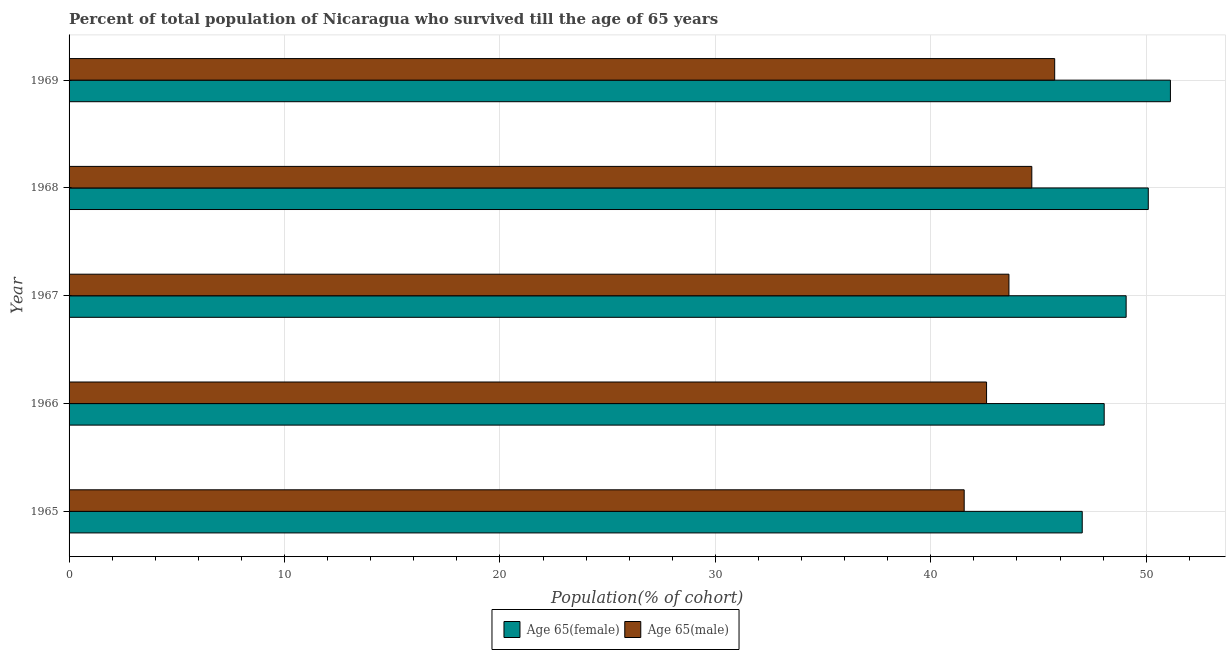How many groups of bars are there?
Give a very brief answer. 5. Are the number of bars per tick equal to the number of legend labels?
Keep it short and to the point. Yes. Are the number of bars on each tick of the Y-axis equal?
Your answer should be very brief. Yes. How many bars are there on the 1st tick from the bottom?
Your answer should be compact. 2. What is the label of the 4th group of bars from the top?
Give a very brief answer. 1966. What is the percentage of male population who survived till age of 65 in 1967?
Give a very brief answer. 43.63. Across all years, what is the maximum percentage of female population who survived till age of 65?
Your answer should be very brief. 51.12. Across all years, what is the minimum percentage of female population who survived till age of 65?
Offer a terse response. 47.03. In which year was the percentage of male population who survived till age of 65 maximum?
Keep it short and to the point. 1969. In which year was the percentage of female population who survived till age of 65 minimum?
Your response must be concise. 1965. What is the total percentage of female population who survived till age of 65 in the graph?
Give a very brief answer. 245.36. What is the difference between the percentage of female population who survived till age of 65 in 1965 and that in 1967?
Make the answer very short. -2.04. What is the difference between the percentage of male population who survived till age of 65 in 1968 and the percentage of female population who survived till age of 65 in 1969?
Keep it short and to the point. -6.43. What is the average percentage of female population who survived till age of 65 per year?
Keep it short and to the point. 49.07. In the year 1966, what is the difference between the percentage of male population who survived till age of 65 and percentage of female population who survived till age of 65?
Make the answer very short. -5.46. In how many years, is the percentage of female population who survived till age of 65 greater than 22 %?
Provide a succinct answer. 5. Is the percentage of female population who survived till age of 65 in 1966 less than that in 1969?
Offer a very short reply. Yes. What is the difference between the highest and the second highest percentage of male population who survived till age of 65?
Offer a terse response. 1.06. What is the difference between the highest and the lowest percentage of male population who survived till age of 65?
Offer a terse response. 4.2. In how many years, is the percentage of female population who survived till age of 65 greater than the average percentage of female population who survived till age of 65 taken over all years?
Provide a succinct answer. 2. What does the 1st bar from the top in 1965 represents?
Offer a very short reply. Age 65(male). What does the 2nd bar from the bottom in 1966 represents?
Make the answer very short. Age 65(male). How many bars are there?
Provide a short and direct response. 10. How many years are there in the graph?
Give a very brief answer. 5. What is the difference between two consecutive major ticks on the X-axis?
Offer a terse response. 10. Are the values on the major ticks of X-axis written in scientific E-notation?
Provide a succinct answer. No. Does the graph contain any zero values?
Give a very brief answer. No. Does the graph contain grids?
Ensure brevity in your answer.  Yes. Where does the legend appear in the graph?
Provide a short and direct response. Bottom center. How many legend labels are there?
Give a very brief answer. 2. How are the legend labels stacked?
Your answer should be very brief. Horizontal. What is the title of the graph?
Offer a terse response. Percent of total population of Nicaragua who survived till the age of 65 years. What is the label or title of the X-axis?
Offer a very short reply. Population(% of cohort). What is the label or title of the Y-axis?
Give a very brief answer. Year. What is the Population(% of cohort) of Age 65(female) in 1965?
Provide a short and direct response. 47.03. What is the Population(% of cohort) of Age 65(male) in 1965?
Make the answer very short. 41.55. What is the Population(% of cohort) in Age 65(female) in 1966?
Keep it short and to the point. 48.05. What is the Population(% of cohort) in Age 65(male) in 1966?
Your response must be concise. 42.59. What is the Population(% of cohort) in Age 65(female) in 1967?
Provide a short and direct response. 49.07. What is the Population(% of cohort) in Age 65(male) in 1967?
Make the answer very short. 43.63. What is the Population(% of cohort) in Age 65(female) in 1968?
Your answer should be compact. 50.09. What is the Population(% of cohort) in Age 65(male) in 1968?
Your response must be concise. 44.69. What is the Population(% of cohort) of Age 65(female) in 1969?
Your answer should be compact. 51.12. What is the Population(% of cohort) in Age 65(male) in 1969?
Offer a very short reply. 45.75. Across all years, what is the maximum Population(% of cohort) of Age 65(female)?
Your response must be concise. 51.12. Across all years, what is the maximum Population(% of cohort) in Age 65(male)?
Provide a short and direct response. 45.75. Across all years, what is the minimum Population(% of cohort) in Age 65(female)?
Ensure brevity in your answer.  47.03. Across all years, what is the minimum Population(% of cohort) in Age 65(male)?
Ensure brevity in your answer.  41.55. What is the total Population(% of cohort) of Age 65(female) in the graph?
Make the answer very short. 245.36. What is the total Population(% of cohort) in Age 65(male) in the graph?
Provide a short and direct response. 218.2. What is the difference between the Population(% of cohort) of Age 65(female) in 1965 and that in 1966?
Ensure brevity in your answer.  -1.02. What is the difference between the Population(% of cohort) in Age 65(male) in 1965 and that in 1966?
Offer a terse response. -1.04. What is the difference between the Population(% of cohort) in Age 65(female) in 1965 and that in 1967?
Give a very brief answer. -2.04. What is the difference between the Population(% of cohort) in Age 65(male) in 1965 and that in 1967?
Give a very brief answer. -2.08. What is the difference between the Population(% of cohort) in Age 65(female) in 1965 and that in 1968?
Make the answer very short. -3.07. What is the difference between the Population(% of cohort) in Age 65(male) in 1965 and that in 1968?
Your answer should be compact. -3.14. What is the difference between the Population(% of cohort) in Age 65(female) in 1965 and that in 1969?
Make the answer very short. -4.09. What is the difference between the Population(% of cohort) of Age 65(male) in 1965 and that in 1969?
Provide a short and direct response. -4.2. What is the difference between the Population(% of cohort) in Age 65(female) in 1966 and that in 1967?
Ensure brevity in your answer.  -1.02. What is the difference between the Population(% of cohort) of Age 65(male) in 1966 and that in 1967?
Offer a terse response. -1.04. What is the difference between the Population(% of cohort) of Age 65(female) in 1966 and that in 1968?
Your answer should be compact. -2.05. What is the difference between the Population(% of cohort) in Age 65(male) in 1966 and that in 1968?
Offer a terse response. -2.1. What is the difference between the Population(% of cohort) of Age 65(female) in 1966 and that in 1969?
Provide a short and direct response. -3.07. What is the difference between the Population(% of cohort) in Age 65(male) in 1966 and that in 1969?
Provide a short and direct response. -3.16. What is the difference between the Population(% of cohort) of Age 65(female) in 1967 and that in 1968?
Provide a short and direct response. -1.03. What is the difference between the Population(% of cohort) in Age 65(male) in 1967 and that in 1968?
Provide a succinct answer. -1.06. What is the difference between the Population(% of cohort) of Age 65(female) in 1967 and that in 1969?
Provide a succinct answer. -2.06. What is the difference between the Population(% of cohort) of Age 65(male) in 1967 and that in 1969?
Provide a short and direct response. -2.12. What is the difference between the Population(% of cohort) of Age 65(female) in 1968 and that in 1969?
Your answer should be very brief. -1.03. What is the difference between the Population(% of cohort) in Age 65(male) in 1968 and that in 1969?
Offer a terse response. -1.06. What is the difference between the Population(% of cohort) in Age 65(female) in 1965 and the Population(% of cohort) in Age 65(male) in 1966?
Provide a short and direct response. 4.44. What is the difference between the Population(% of cohort) in Age 65(female) in 1965 and the Population(% of cohort) in Age 65(male) in 1967?
Make the answer very short. 3.4. What is the difference between the Population(% of cohort) in Age 65(female) in 1965 and the Population(% of cohort) in Age 65(male) in 1968?
Ensure brevity in your answer.  2.34. What is the difference between the Population(% of cohort) in Age 65(female) in 1965 and the Population(% of cohort) in Age 65(male) in 1969?
Provide a short and direct response. 1.28. What is the difference between the Population(% of cohort) in Age 65(female) in 1966 and the Population(% of cohort) in Age 65(male) in 1967?
Your response must be concise. 4.42. What is the difference between the Population(% of cohort) of Age 65(female) in 1966 and the Population(% of cohort) of Age 65(male) in 1968?
Your answer should be very brief. 3.36. What is the difference between the Population(% of cohort) of Age 65(female) in 1966 and the Population(% of cohort) of Age 65(male) in 1969?
Make the answer very short. 2.3. What is the difference between the Population(% of cohort) of Age 65(female) in 1967 and the Population(% of cohort) of Age 65(male) in 1968?
Your response must be concise. 4.38. What is the difference between the Population(% of cohort) in Age 65(female) in 1967 and the Population(% of cohort) in Age 65(male) in 1969?
Make the answer very short. 3.32. What is the difference between the Population(% of cohort) of Age 65(female) in 1968 and the Population(% of cohort) of Age 65(male) in 1969?
Provide a succinct answer. 4.34. What is the average Population(% of cohort) of Age 65(female) per year?
Keep it short and to the point. 49.07. What is the average Population(% of cohort) of Age 65(male) per year?
Provide a short and direct response. 43.64. In the year 1965, what is the difference between the Population(% of cohort) in Age 65(female) and Population(% of cohort) in Age 65(male)?
Your answer should be very brief. 5.48. In the year 1966, what is the difference between the Population(% of cohort) of Age 65(female) and Population(% of cohort) of Age 65(male)?
Give a very brief answer. 5.46. In the year 1967, what is the difference between the Population(% of cohort) of Age 65(female) and Population(% of cohort) of Age 65(male)?
Keep it short and to the point. 5.44. In the year 1968, what is the difference between the Population(% of cohort) in Age 65(female) and Population(% of cohort) in Age 65(male)?
Keep it short and to the point. 5.41. In the year 1969, what is the difference between the Population(% of cohort) of Age 65(female) and Population(% of cohort) of Age 65(male)?
Your response must be concise. 5.37. What is the ratio of the Population(% of cohort) of Age 65(female) in 1965 to that in 1966?
Ensure brevity in your answer.  0.98. What is the ratio of the Population(% of cohort) of Age 65(male) in 1965 to that in 1966?
Offer a terse response. 0.98. What is the ratio of the Population(% of cohort) of Age 65(female) in 1965 to that in 1967?
Offer a terse response. 0.96. What is the ratio of the Population(% of cohort) in Age 65(male) in 1965 to that in 1967?
Offer a very short reply. 0.95. What is the ratio of the Population(% of cohort) in Age 65(female) in 1965 to that in 1968?
Provide a succinct answer. 0.94. What is the ratio of the Population(% of cohort) of Age 65(male) in 1965 to that in 1968?
Your response must be concise. 0.93. What is the ratio of the Population(% of cohort) of Age 65(female) in 1965 to that in 1969?
Your answer should be very brief. 0.92. What is the ratio of the Population(% of cohort) of Age 65(male) in 1965 to that in 1969?
Offer a terse response. 0.91. What is the ratio of the Population(% of cohort) of Age 65(female) in 1966 to that in 1967?
Keep it short and to the point. 0.98. What is the ratio of the Population(% of cohort) of Age 65(male) in 1966 to that in 1967?
Your answer should be very brief. 0.98. What is the ratio of the Population(% of cohort) of Age 65(female) in 1966 to that in 1968?
Offer a very short reply. 0.96. What is the ratio of the Population(% of cohort) of Age 65(male) in 1966 to that in 1968?
Give a very brief answer. 0.95. What is the ratio of the Population(% of cohort) in Age 65(female) in 1966 to that in 1969?
Provide a succinct answer. 0.94. What is the ratio of the Population(% of cohort) in Age 65(male) in 1966 to that in 1969?
Provide a short and direct response. 0.93. What is the ratio of the Population(% of cohort) in Age 65(female) in 1967 to that in 1968?
Your answer should be very brief. 0.98. What is the ratio of the Population(% of cohort) in Age 65(male) in 1967 to that in 1968?
Your answer should be very brief. 0.98. What is the ratio of the Population(% of cohort) of Age 65(female) in 1967 to that in 1969?
Provide a succinct answer. 0.96. What is the ratio of the Population(% of cohort) of Age 65(male) in 1967 to that in 1969?
Keep it short and to the point. 0.95. What is the ratio of the Population(% of cohort) in Age 65(female) in 1968 to that in 1969?
Make the answer very short. 0.98. What is the ratio of the Population(% of cohort) in Age 65(male) in 1968 to that in 1969?
Offer a very short reply. 0.98. What is the difference between the highest and the second highest Population(% of cohort) in Age 65(female)?
Ensure brevity in your answer.  1.03. What is the difference between the highest and the second highest Population(% of cohort) of Age 65(male)?
Offer a very short reply. 1.06. What is the difference between the highest and the lowest Population(% of cohort) of Age 65(female)?
Provide a succinct answer. 4.09. What is the difference between the highest and the lowest Population(% of cohort) of Age 65(male)?
Ensure brevity in your answer.  4.2. 